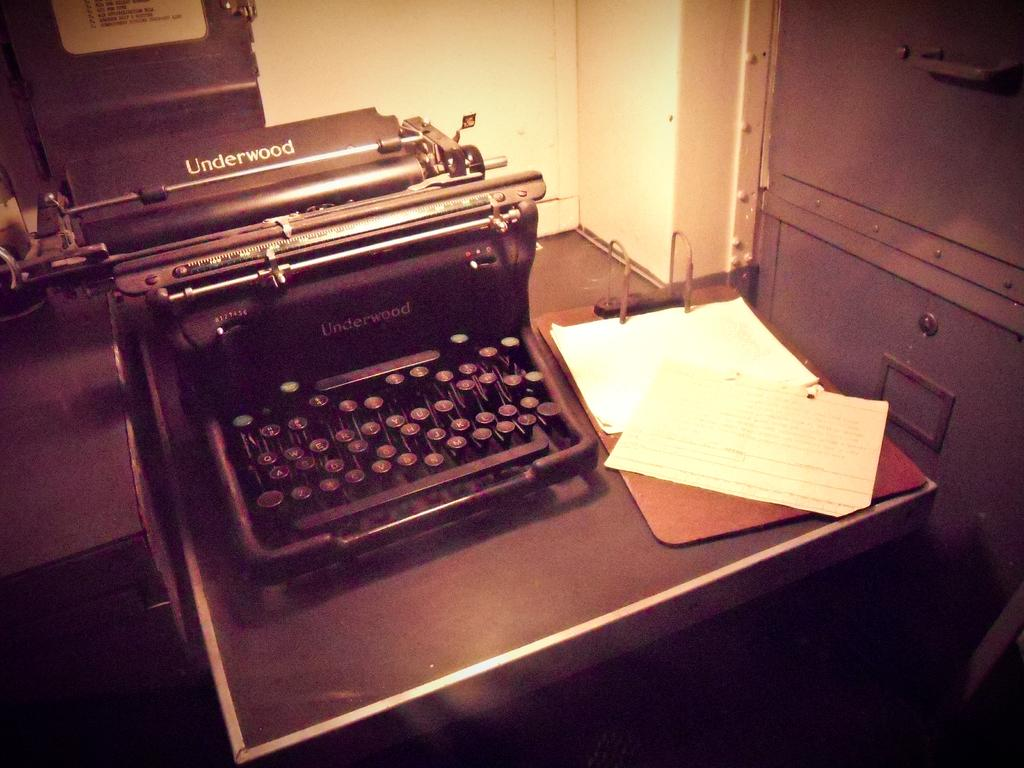Provide a one-sentence caption for the provided image. Typewrite that is from Underwood with a clipboard beside it that got paper on it. 